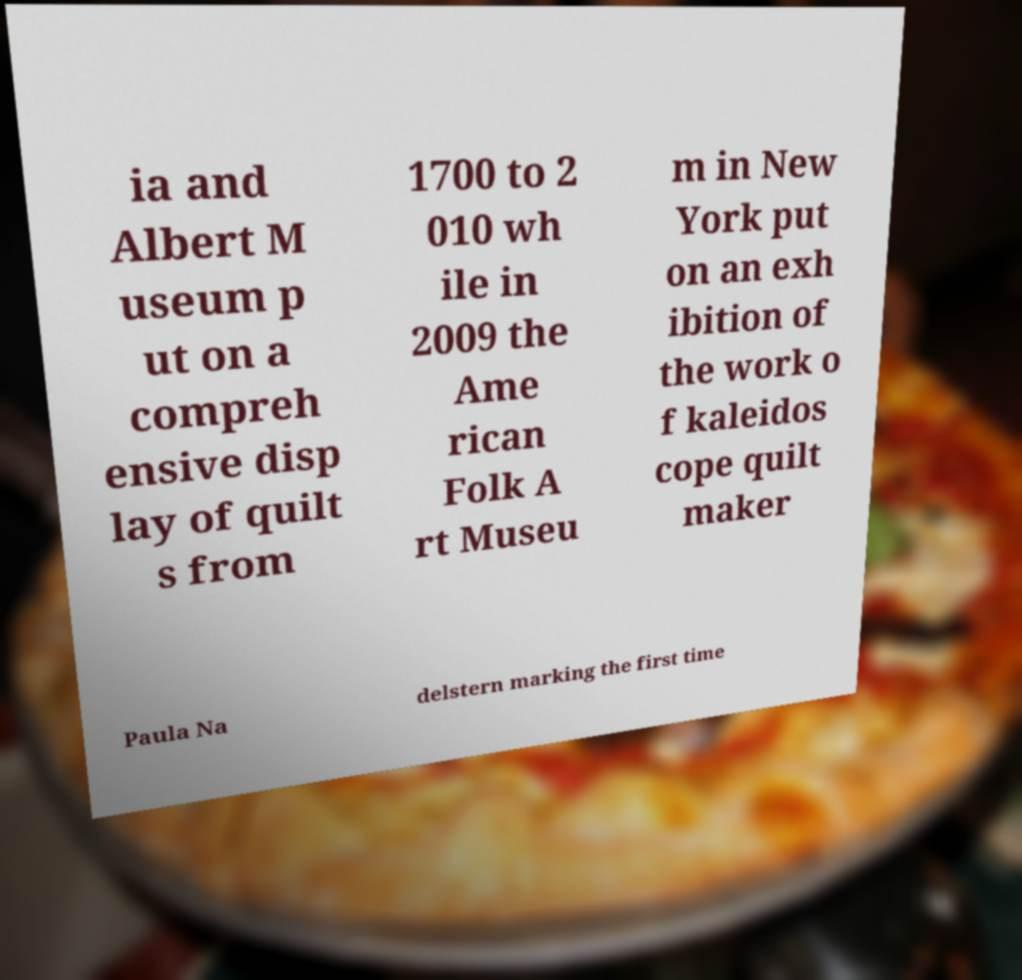For documentation purposes, I need the text within this image transcribed. Could you provide that? ia and Albert M useum p ut on a compreh ensive disp lay of quilt s from 1700 to 2 010 wh ile in 2009 the Ame rican Folk A rt Museu m in New York put on an exh ibition of the work o f kaleidos cope quilt maker Paula Na delstern marking the first time 